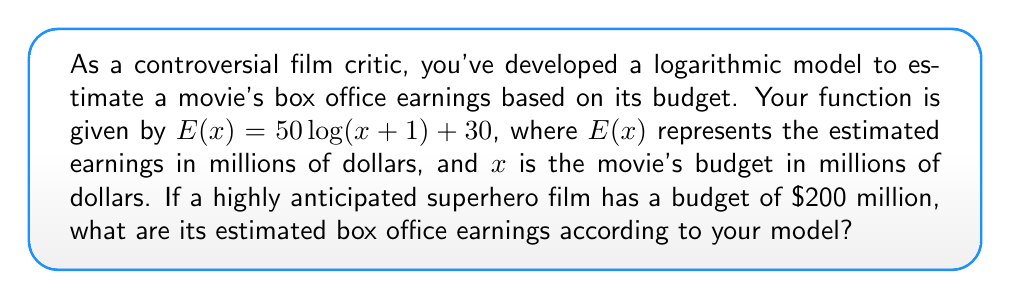Can you answer this question? Let's approach this step-by-step:

1) We're given the logarithmic function: $E(x) = 50\log(x+1) + 30$

2) In this function:
   - $E(x)$ is the estimated earnings in millions of dollars
   - $x$ is the movie's budget in millions of dollars
   - We're using the natural logarithm (base e)

3) We need to find $E(200)$, as the movie's budget is $200 million

4) Let's substitute $x = 200$ into our function:

   $E(200) = 50\log(200+1) + 30$

5) Simplify inside the parentheses:
   
   $E(200) = 50\log(201) + 30$

6) Use a calculator to evaluate $\log(201)$:
   
   $\log(201) \approx 5.3033$

7) Multiply this by 50:
   
   $50 * 5.3033 \approx 265.165$

8) Add 30:
   
   $265.165 + 30 = 295.165$

9) Round to the nearest million dollars:

   $295.165 million \approx 295 million$

Therefore, according to your controversial model, the estimated box office earnings for this superhero film would be approximately $295 million.
Answer: $295 million 